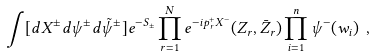Convert formula to latex. <formula><loc_0><loc_0><loc_500><loc_500>\int [ d X ^ { \pm } d \psi ^ { \pm } d \tilde { \psi } ^ { \pm } ] e ^ { - S _ { \pm } } \prod _ { r = 1 } ^ { N } e ^ { - i p _ { r } ^ { + } X ^ { - } } ( Z _ { r } , \bar { Z } _ { r } ) \prod _ { i = 1 } ^ { n } \psi ^ { - } ( w _ { i } ) \ ,</formula> 